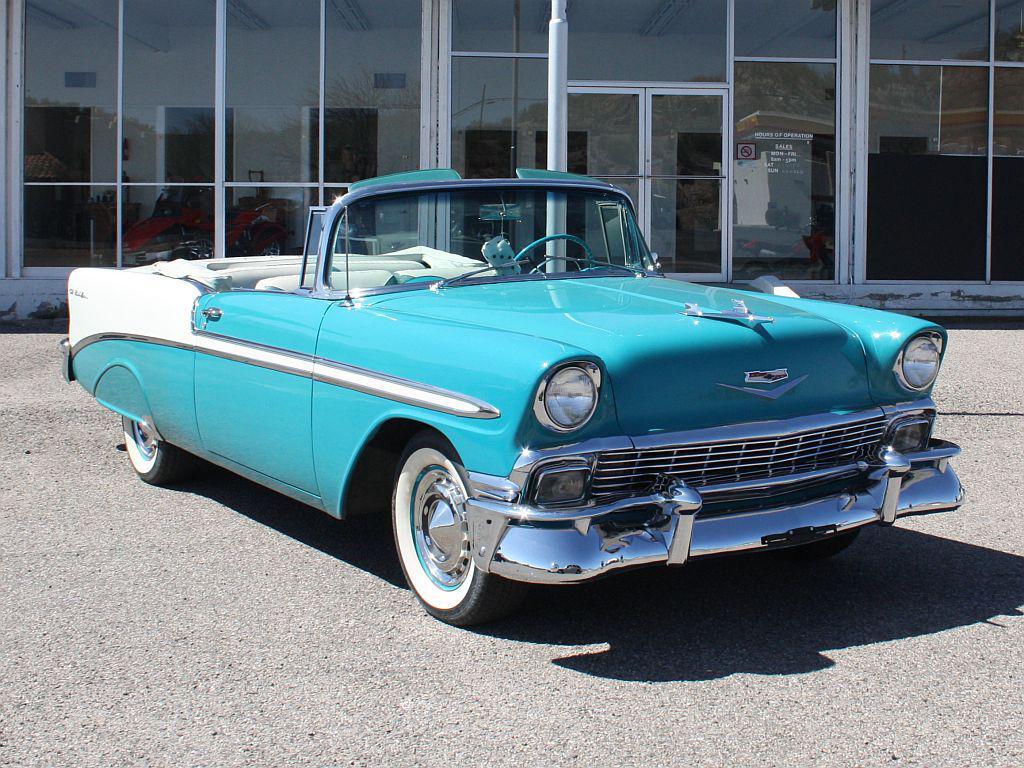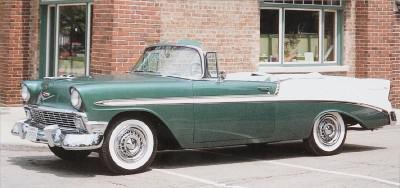The first image is the image on the left, the second image is the image on the right. Assess this claim about the two images: "At least one of the cars is parked near the grass.". Correct or not? Answer yes or no. No. 